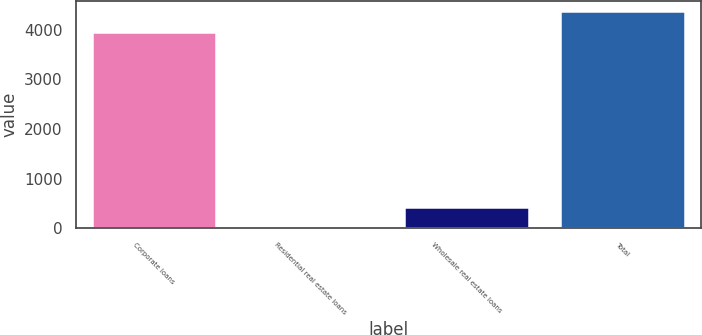Convert chart to OTSL. <chart><loc_0><loc_0><loc_500><loc_500><bar_chart><fcel>Corporate loans<fcel>Residential real estate loans<fcel>Wholesale real estate loans<fcel>Total<nl><fcel>3957<fcel>8<fcel>421.1<fcel>4370.1<nl></chart> 